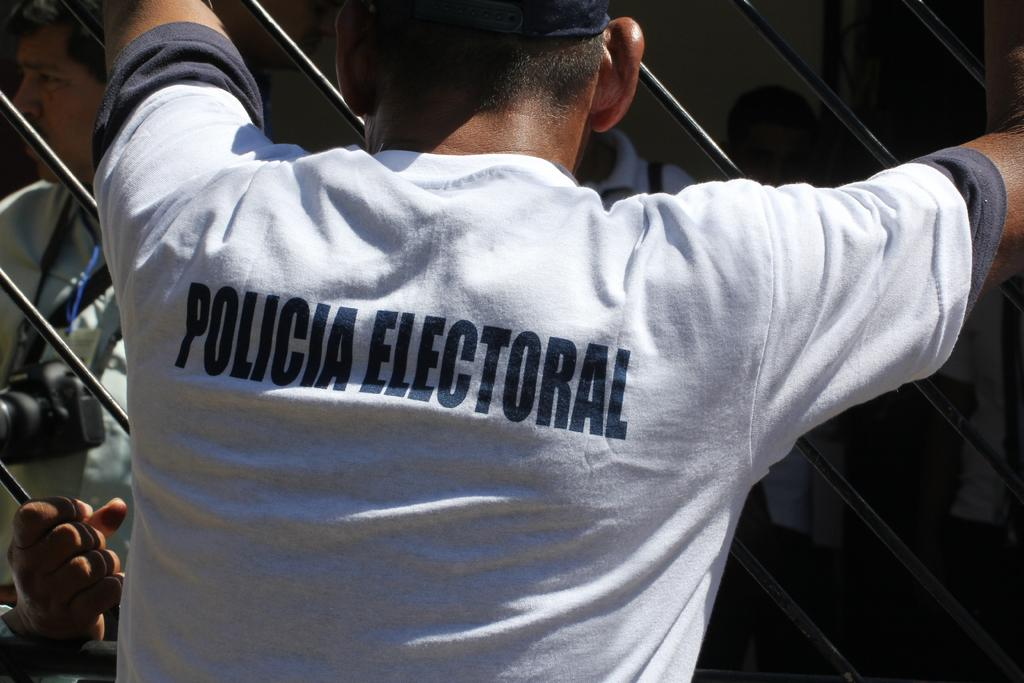Provide a one-sentence caption for the provided image. A man is wearing a shirt with the words policia electoral on the back. 